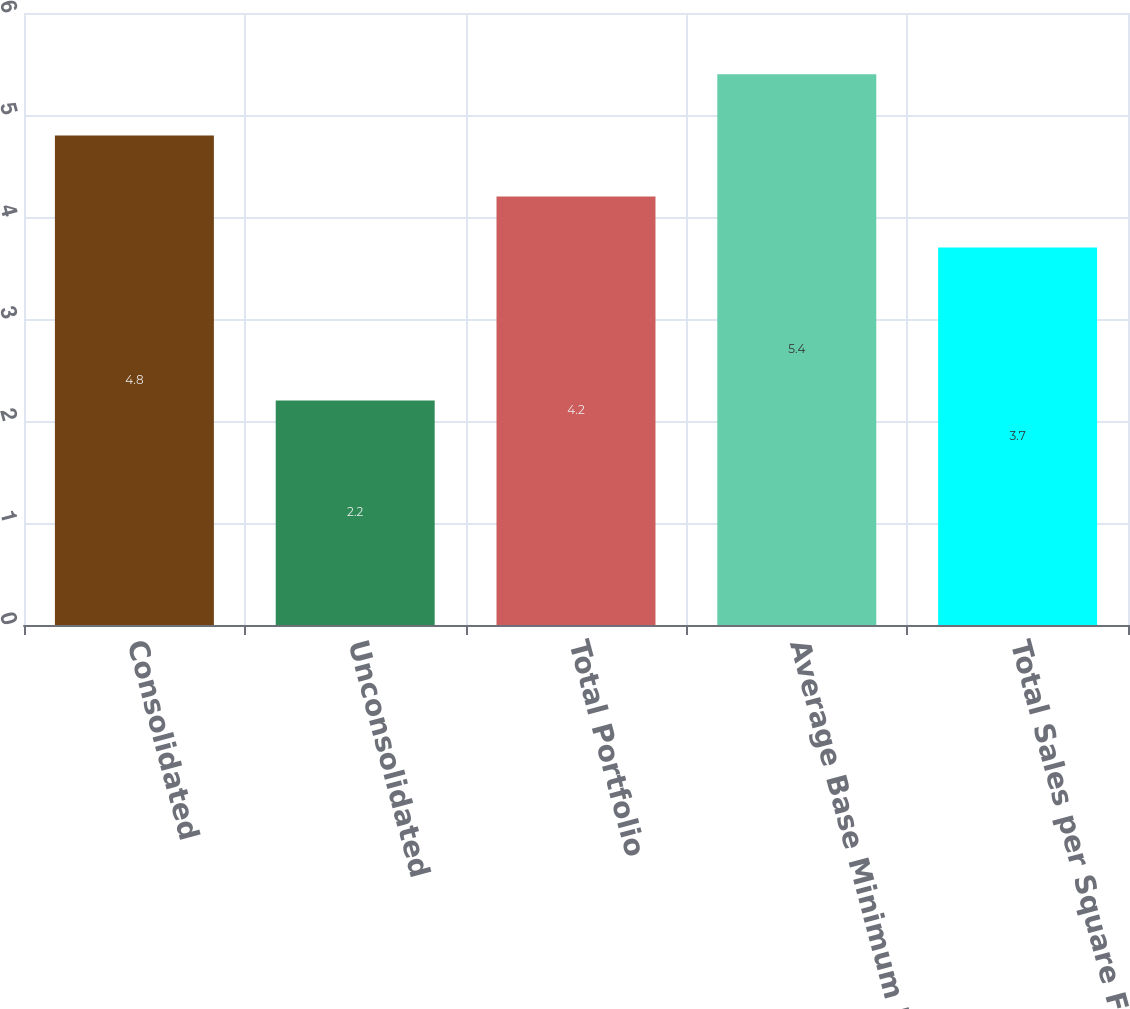<chart> <loc_0><loc_0><loc_500><loc_500><bar_chart><fcel>Consolidated<fcel>Unconsolidated<fcel>Total Portfolio<fcel>Average Base Minimum Rent per<fcel>Total Sales per Square Foot<nl><fcel>4.8<fcel>2.2<fcel>4.2<fcel>5.4<fcel>3.7<nl></chart> 